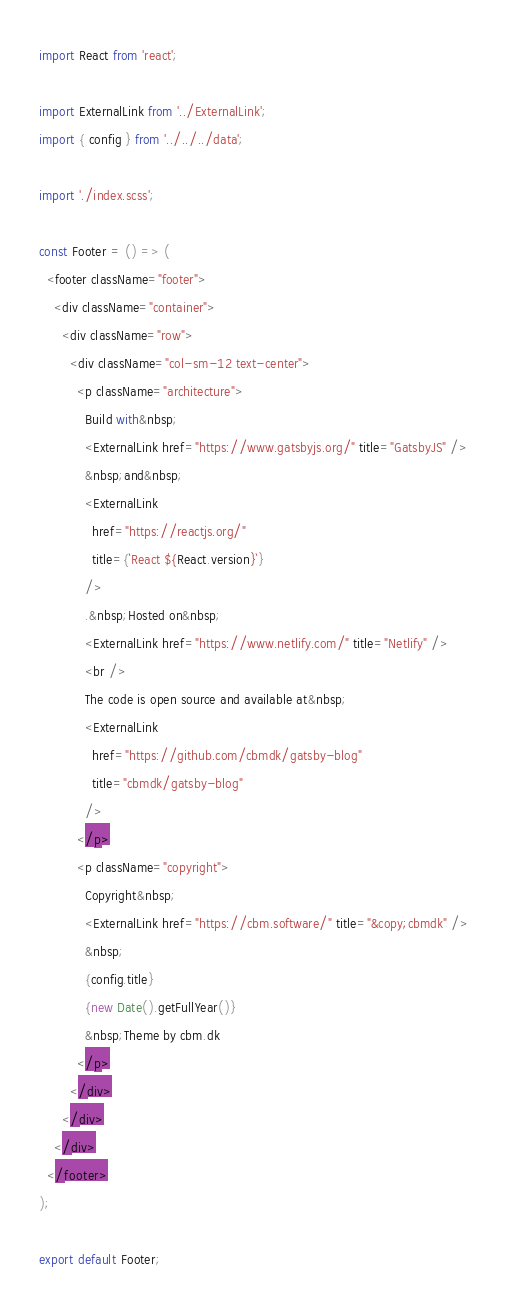<code> <loc_0><loc_0><loc_500><loc_500><_JavaScript_>import React from 'react';

import ExternalLink from '../ExternalLink';
import { config } from '../../../data';

import './index.scss';

const Footer = () => (
  <footer className="footer">
    <div className="container">
      <div className="row">
        <div className="col-sm-12 text-center">
          <p className="architecture">
            Build with&nbsp;
            <ExternalLink href="https://www.gatsbyjs.org/" title="GatsbyJS" />
            &nbsp;and&nbsp;
            <ExternalLink
              href="https://reactjs.org/"
              title={`React ${React.version}`}
            />
            .&nbsp;Hosted on&nbsp;
            <ExternalLink href="https://www.netlify.com/" title="Netlify" />
            <br />
            The code is open source and available at&nbsp;
            <ExternalLink
              href="https://github.com/cbmdk/gatsby-blog"
              title="cbmdk/gatsby-blog"
            />
          </p>
          <p className="copyright">
            Copyright&nbsp;
            <ExternalLink href="https://cbm.software/" title="&copy;cbmdk" />
            &nbsp;
            {config.title}
            {new Date().getFullYear()}
            &nbsp;Theme by cbm.dk
          </p>
        </div>
      </div>
    </div>
  </footer>
);

export default Footer;
</code> 